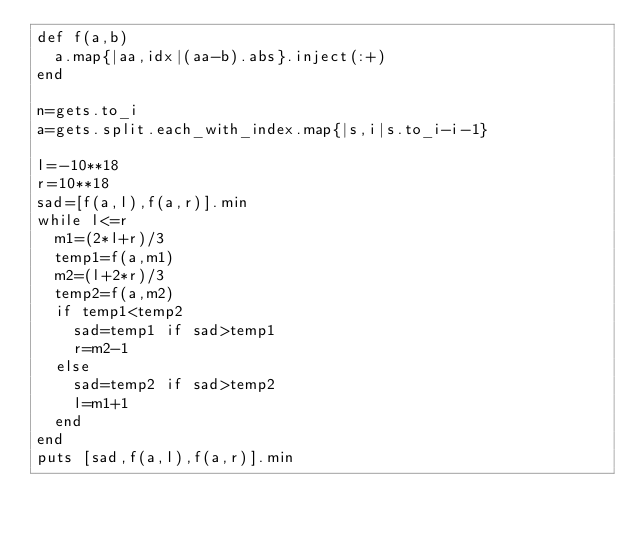<code> <loc_0><loc_0><loc_500><loc_500><_Ruby_>def f(a,b)
  a.map{|aa,idx|(aa-b).abs}.inject(:+) 
end

n=gets.to_i
a=gets.split.each_with_index.map{|s,i|s.to_i-i-1}

l=-10**18
r=10**18
sad=[f(a,l),f(a,r)].min
while l<=r
  m1=(2*l+r)/3
  temp1=f(a,m1)
  m2=(l+2*r)/3
  temp2=f(a,m2)
  if temp1<temp2
    sad=temp1 if sad>temp1
    r=m2-1
  else
    sad=temp2 if sad>temp2
    l=m1+1
  end
end
puts [sad,f(a,l),f(a,r)].min</code> 